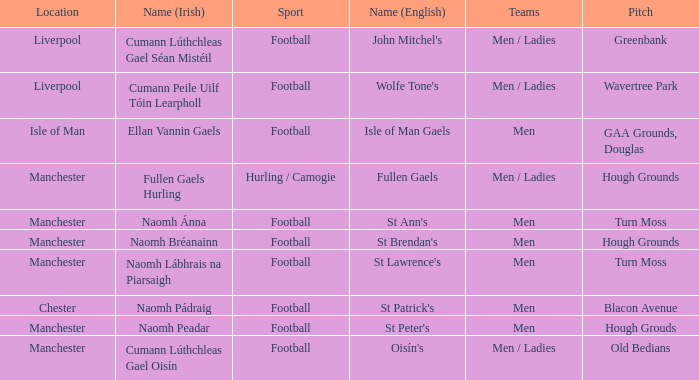What is the Location of the Old Bedians Pitch? Manchester. 